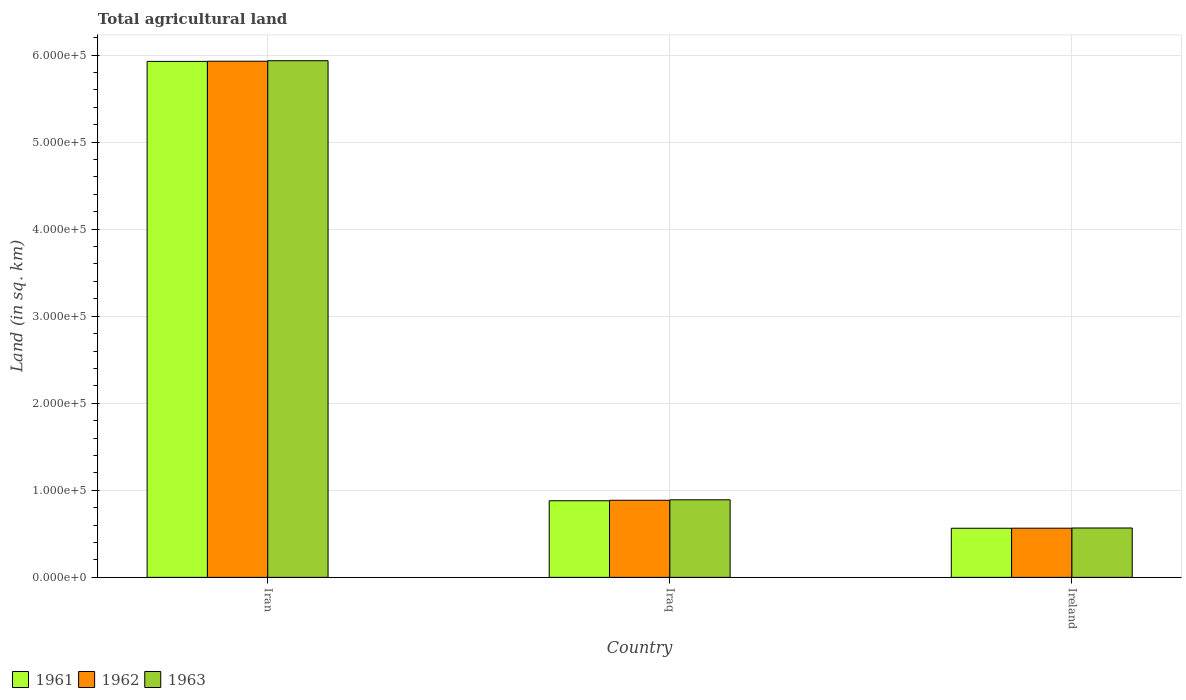How many different coloured bars are there?
Your answer should be compact. 3. How many groups of bars are there?
Give a very brief answer. 3. Are the number of bars per tick equal to the number of legend labels?
Your answer should be very brief. Yes. What is the label of the 3rd group of bars from the left?
Keep it short and to the point. Ireland. In how many cases, is the number of bars for a given country not equal to the number of legend labels?
Ensure brevity in your answer.  0. What is the total agricultural land in 1962 in Ireland?
Your answer should be compact. 5.65e+04. Across all countries, what is the maximum total agricultural land in 1961?
Your answer should be compact. 5.93e+05. Across all countries, what is the minimum total agricultural land in 1962?
Ensure brevity in your answer.  5.65e+04. In which country was the total agricultural land in 1963 maximum?
Offer a very short reply. Iran. In which country was the total agricultural land in 1961 minimum?
Your response must be concise. Ireland. What is the total total agricultural land in 1963 in the graph?
Offer a terse response. 7.39e+05. What is the difference between the total agricultural land in 1961 in Iran and that in Iraq?
Your response must be concise. 5.05e+05. What is the difference between the total agricultural land in 1961 in Iraq and the total agricultural land in 1962 in Ireland?
Make the answer very short. 3.15e+04. What is the average total agricultural land in 1961 per country?
Provide a succinct answer. 2.46e+05. What is the difference between the total agricultural land of/in 1963 and total agricultural land of/in 1962 in Iraq?
Your response must be concise. 550. In how many countries, is the total agricultural land in 1961 greater than 40000 sq.km?
Make the answer very short. 3. What is the ratio of the total agricultural land in 1961 in Iraq to that in Ireland?
Make the answer very short. 1.56. What is the difference between the highest and the second highest total agricultural land in 1963?
Keep it short and to the point. 5.04e+05. What is the difference between the highest and the lowest total agricultural land in 1962?
Give a very brief answer. 5.36e+05. What does the 1st bar from the left in Iran represents?
Provide a short and direct response. 1961. Is it the case that in every country, the sum of the total agricultural land in 1963 and total agricultural land in 1961 is greater than the total agricultural land in 1962?
Your answer should be compact. Yes. How many bars are there?
Offer a very short reply. 9. Are all the bars in the graph horizontal?
Provide a succinct answer. No. How many countries are there in the graph?
Offer a very short reply. 3. Does the graph contain grids?
Offer a very short reply. Yes. Where does the legend appear in the graph?
Make the answer very short. Bottom left. How many legend labels are there?
Your answer should be compact. 3. What is the title of the graph?
Offer a terse response. Total agricultural land. Does "1971" appear as one of the legend labels in the graph?
Give a very brief answer. No. What is the label or title of the Y-axis?
Ensure brevity in your answer.  Land (in sq. km). What is the Land (in sq. km) of 1961 in Iran?
Provide a succinct answer. 5.93e+05. What is the Land (in sq. km) of 1962 in Iran?
Keep it short and to the point. 5.93e+05. What is the Land (in sq. km) of 1963 in Iran?
Your answer should be very brief. 5.94e+05. What is the Land (in sq. km) of 1961 in Iraq?
Offer a terse response. 8.80e+04. What is the Land (in sq. km) in 1962 in Iraq?
Offer a terse response. 8.86e+04. What is the Land (in sq. km) in 1963 in Iraq?
Ensure brevity in your answer.  8.91e+04. What is the Land (in sq. km) of 1961 in Ireland?
Give a very brief answer. 5.64e+04. What is the Land (in sq. km) of 1962 in Ireland?
Keep it short and to the point. 5.65e+04. What is the Land (in sq. km) of 1963 in Ireland?
Ensure brevity in your answer.  5.67e+04. Across all countries, what is the maximum Land (in sq. km) in 1961?
Your answer should be compact. 5.93e+05. Across all countries, what is the maximum Land (in sq. km) of 1962?
Offer a terse response. 5.93e+05. Across all countries, what is the maximum Land (in sq. km) of 1963?
Give a very brief answer. 5.94e+05. Across all countries, what is the minimum Land (in sq. km) in 1961?
Your answer should be compact. 5.64e+04. Across all countries, what is the minimum Land (in sq. km) in 1962?
Provide a short and direct response. 5.65e+04. Across all countries, what is the minimum Land (in sq. km) of 1963?
Give a very brief answer. 5.67e+04. What is the total Land (in sq. km) in 1961 in the graph?
Your answer should be compact. 7.37e+05. What is the total Land (in sq. km) in 1962 in the graph?
Your response must be concise. 7.38e+05. What is the total Land (in sq. km) of 1963 in the graph?
Provide a short and direct response. 7.39e+05. What is the difference between the Land (in sq. km) of 1961 in Iran and that in Iraq?
Your answer should be very brief. 5.05e+05. What is the difference between the Land (in sq. km) in 1962 in Iran and that in Iraq?
Offer a terse response. 5.04e+05. What is the difference between the Land (in sq. km) in 1963 in Iran and that in Iraq?
Your response must be concise. 5.04e+05. What is the difference between the Land (in sq. km) in 1961 in Iran and that in Ireland?
Offer a very short reply. 5.36e+05. What is the difference between the Land (in sq. km) in 1962 in Iran and that in Ireland?
Offer a terse response. 5.36e+05. What is the difference between the Land (in sq. km) of 1963 in Iran and that in Ireland?
Your answer should be compact. 5.37e+05. What is the difference between the Land (in sq. km) of 1961 in Iraq and that in Ireland?
Provide a succinct answer. 3.16e+04. What is the difference between the Land (in sq. km) of 1962 in Iraq and that in Ireland?
Keep it short and to the point. 3.21e+04. What is the difference between the Land (in sq. km) in 1963 in Iraq and that in Ireland?
Make the answer very short. 3.24e+04. What is the difference between the Land (in sq. km) in 1961 in Iran and the Land (in sq. km) in 1962 in Iraq?
Give a very brief answer. 5.04e+05. What is the difference between the Land (in sq. km) in 1961 in Iran and the Land (in sq. km) in 1963 in Iraq?
Ensure brevity in your answer.  5.04e+05. What is the difference between the Land (in sq. km) in 1962 in Iran and the Land (in sq. km) in 1963 in Iraq?
Your response must be concise. 5.04e+05. What is the difference between the Land (in sq. km) in 1961 in Iran and the Land (in sq. km) in 1962 in Ireland?
Ensure brevity in your answer.  5.36e+05. What is the difference between the Land (in sq. km) of 1961 in Iran and the Land (in sq. km) of 1963 in Ireland?
Offer a very short reply. 5.36e+05. What is the difference between the Land (in sq. km) of 1962 in Iran and the Land (in sq. km) of 1963 in Ireland?
Provide a short and direct response. 5.36e+05. What is the difference between the Land (in sq. km) of 1961 in Iraq and the Land (in sq. km) of 1962 in Ireland?
Your answer should be compact. 3.15e+04. What is the difference between the Land (in sq. km) in 1961 in Iraq and the Land (in sq. km) in 1963 in Ireland?
Offer a very short reply. 3.13e+04. What is the difference between the Land (in sq. km) in 1962 in Iraq and the Land (in sq. km) in 1963 in Ireland?
Offer a terse response. 3.18e+04. What is the average Land (in sq. km) of 1961 per country?
Provide a short and direct response. 2.46e+05. What is the average Land (in sq. km) of 1962 per country?
Offer a very short reply. 2.46e+05. What is the average Land (in sq. km) in 1963 per country?
Give a very brief answer. 2.46e+05. What is the difference between the Land (in sq. km) of 1961 and Land (in sq. km) of 1962 in Iran?
Your answer should be very brief. -190. What is the difference between the Land (in sq. km) of 1961 and Land (in sq. km) of 1963 in Iran?
Your answer should be very brief. -790. What is the difference between the Land (in sq. km) in 1962 and Land (in sq. km) in 1963 in Iran?
Provide a succinct answer. -600. What is the difference between the Land (in sq. km) in 1961 and Land (in sq. km) in 1962 in Iraq?
Keep it short and to the point. -550. What is the difference between the Land (in sq. km) of 1961 and Land (in sq. km) of 1963 in Iraq?
Offer a terse response. -1100. What is the difference between the Land (in sq. km) in 1962 and Land (in sq. km) in 1963 in Iraq?
Your answer should be compact. -550. What is the difference between the Land (in sq. km) of 1961 and Land (in sq. km) of 1962 in Ireland?
Offer a very short reply. -70. What is the difference between the Land (in sq. km) of 1961 and Land (in sq. km) of 1963 in Ireland?
Give a very brief answer. -310. What is the difference between the Land (in sq. km) in 1962 and Land (in sq. km) in 1963 in Ireland?
Give a very brief answer. -240. What is the ratio of the Land (in sq. km) of 1961 in Iran to that in Iraq?
Keep it short and to the point. 6.74. What is the ratio of the Land (in sq. km) of 1962 in Iran to that in Iraq?
Your answer should be very brief. 6.7. What is the ratio of the Land (in sq. km) of 1963 in Iran to that in Iraq?
Offer a very short reply. 6.66. What is the ratio of the Land (in sq. km) in 1961 in Iran to that in Ireland?
Ensure brevity in your answer.  10.51. What is the ratio of the Land (in sq. km) of 1962 in Iran to that in Ireland?
Your response must be concise. 10.5. What is the ratio of the Land (in sq. km) of 1963 in Iran to that in Ireland?
Make the answer very short. 10.47. What is the ratio of the Land (in sq. km) in 1961 in Iraq to that in Ireland?
Your answer should be compact. 1.56. What is the ratio of the Land (in sq. km) in 1962 in Iraq to that in Ireland?
Give a very brief answer. 1.57. What is the ratio of the Land (in sq. km) in 1963 in Iraq to that in Ireland?
Keep it short and to the point. 1.57. What is the difference between the highest and the second highest Land (in sq. km) of 1961?
Provide a succinct answer. 5.05e+05. What is the difference between the highest and the second highest Land (in sq. km) in 1962?
Offer a terse response. 5.04e+05. What is the difference between the highest and the second highest Land (in sq. km) of 1963?
Provide a succinct answer. 5.04e+05. What is the difference between the highest and the lowest Land (in sq. km) of 1961?
Ensure brevity in your answer.  5.36e+05. What is the difference between the highest and the lowest Land (in sq. km) of 1962?
Provide a short and direct response. 5.36e+05. What is the difference between the highest and the lowest Land (in sq. km) of 1963?
Offer a very short reply. 5.37e+05. 